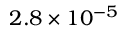<formula> <loc_0><loc_0><loc_500><loc_500>2 . 8 \times 1 0 ^ { - 5 }</formula> 